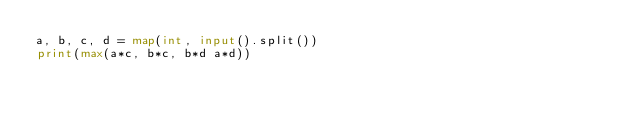Convert code to text. <code><loc_0><loc_0><loc_500><loc_500><_Python_>a, b, c, d = map(int, input().split())
print(max(a*c, b*c, b*d a*d))
</code> 